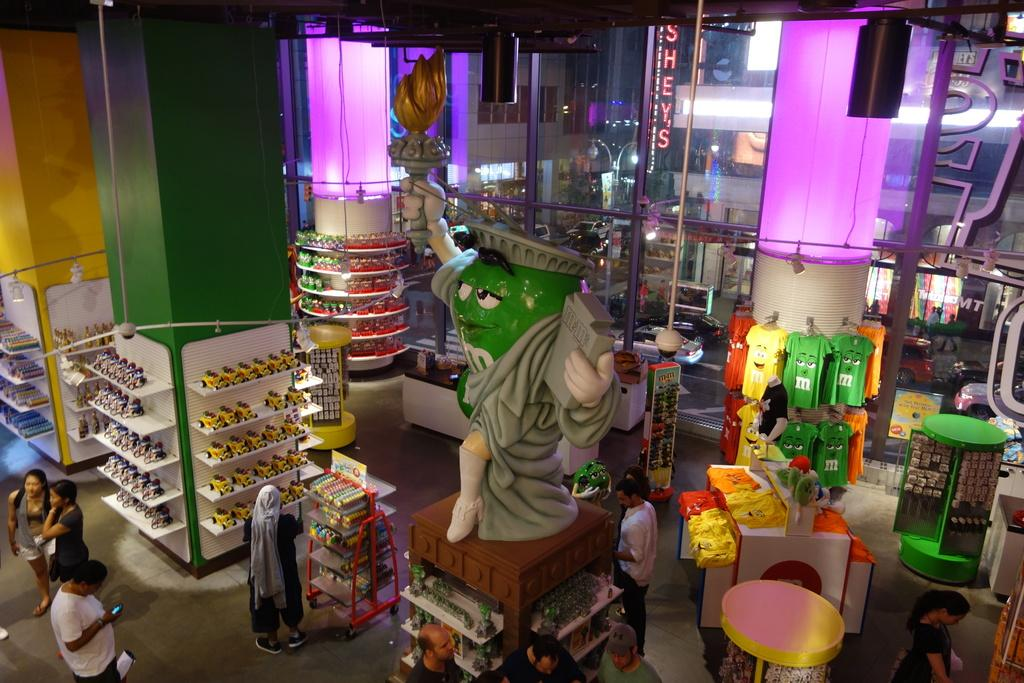What can be seen in the image involving people? There are people standing in the image. What other objects are present in the image besides people? There are toys and t-shirts in the image. How many dogs are visible in the image? There are no dogs present in the image. What type of jar is being used to store the t-shirts in the image? There is no jar present in the image; the t-shirts are not stored in a jar. 